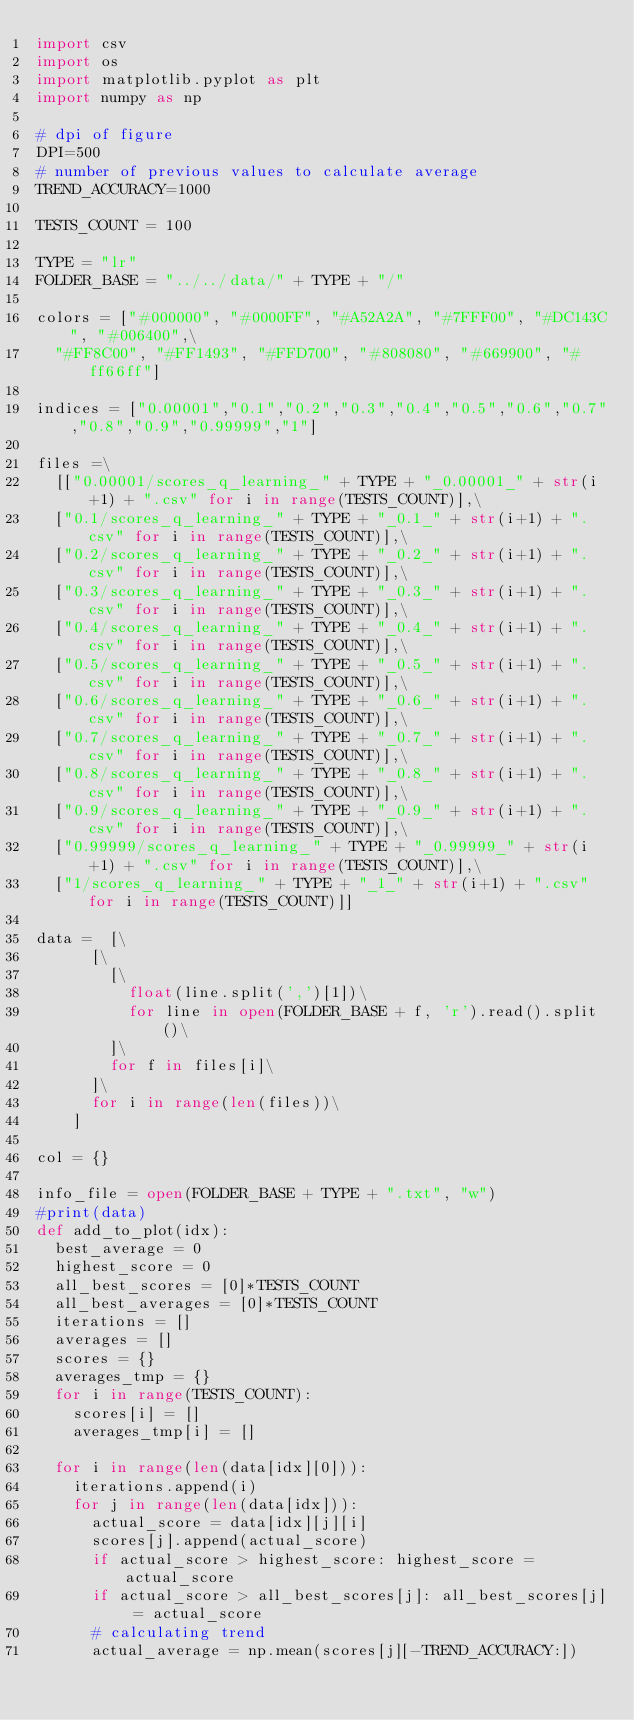Convert code to text. <code><loc_0><loc_0><loc_500><loc_500><_Python_>import csv
import os
import matplotlib.pyplot as plt
import numpy as np

# dpi of figure
DPI=500
# number of previous values to calculate average
TREND_ACCURACY=1000

TESTS_COUNT = 100

TYPE = "lr"
FOLDER_BASE = "../../data/" + TYPE + "/"

colors = ["#000000", "#0000FF", "#A52A2A", "#7FFF00", "#DC143C", "#006400",\
	"#FF8C00", "#FF1493", "#FFD700", "#808080", "#669900", "#ff66ff"]

indices = ["0.00001","0.1","0.2","0.3","0.4","0.5","0.6","0.7","0.8","0.9","0.99999","1"]

files =\
	[["0.00001/scores_q_learning_" + TYPE + "_0.00001_" + str(i+1) + ".csv" for i in range(TESTS_COUNT)],\
	["0.1/scores_q_learning_" + TYPE + "_0.1_" + str(i+1) + ".csv" for i in range(TESTS_COUNT)],\
	["0.2/scores_q_learning_" + TYPE + "_0.2_" + str(i+1) + ".csv" for i in range(TESTS_COUNT)],\
	["0.3/scores_q_learning_" + TYPE + "_0.3_" + str(i+1) + ".csv" for i in range(TESTS_COUNT)],\
	["0.4/scores_q_learning_" + TYPE + "_0.4_" + str(i+1) + ".csv" for i in range(TESTS_COUNT)],\
	["0.5/scores_q_learning_" + TYPE + "_0.5_" + str(i+1) + ".csv" for i in range(TESTS_COUNT)],\
	["0.6/scores_q_learning_" + TYPE + "_0.6_" + str(i+1) + ".csv" for i in range(TESTS_COUNT)],\
	["0.7/scores_q_learning_" + TYPE + "_0.7_" + str(i+1) + ".csv" for i in range(TESTS_COUNT)],\
	["0.8/scores_q_learning_" + TYPE + "_0.8_" + str(i+1) + ".csv" for i in range(TESTS_COUNT)],\
	["0.9/scores_q_learning_" + TYPE + "_0.9_" + str(i+1) + ".csv" for i in range(TESTS_COUNT)],\
	["0.99999/scores_q_learning_" + TYPE + "_0.99999_" + str(i+1) + ".csv" for i in range(TESTS_COUNT)],\
	["1/scores_q_learning_" + TYPE + "_1_" + str(i+1) + ".csv" for i in range(TESTS_COUNT)]]

data = 	[\
			[\
				[\
					float(line.split(',')[1])\
					for line in open(FOLDER_BASE + f, 'r').read().split()\
				]\
				for f in files[i]\
			]\
			for i in range(len(files))\
		]

col = {}

info_file = open(FOLDER_BASE + TYPE + ".txt", "w")
#print(data)
def add_to_plot(idx):
	best_average = 0
	highest_score = 0
	all_best_scores = [0]*TESTS_COUNT
	all_best_averages = [0]*TESTS_COUNT
	iterations = []
	averages = []
	scores = {}
	averages_tmp = {}
	for i in range(TESTS_COUNT):
		scores[i] = []
		averages_tmp[i] = []

	for i in range(len(data[idx][0])):
		iterations.append(i)
		for j in range(len(data[idx])):
			actual_score = data[idx][j][i]
			scores[j].append(actual_score)
			if actual_score > highest_score: highest_score = actual_score
			if actual_score > all_best_scores[j]: all_best_scores[j] = actual_score
			# calculating trend
			actual_average = np.mean(scores[j][-TREND_ACCURACY:])</code> 